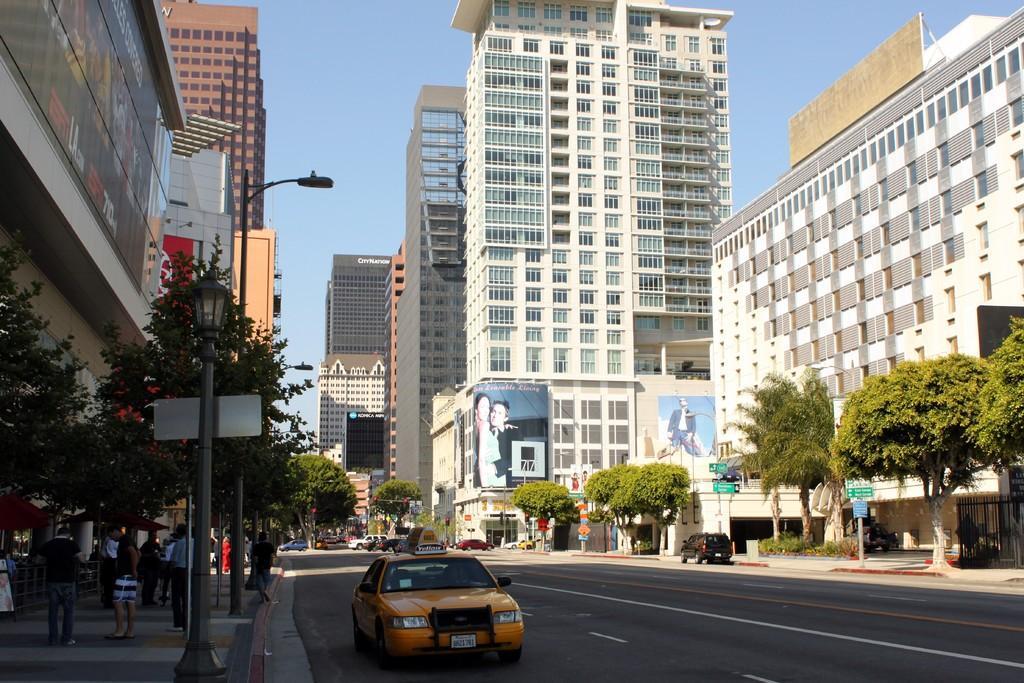Can you describe this image briefly? In the image we can see some buildings, trees, plants, vehicles, boards, posters, people and some other things around. 